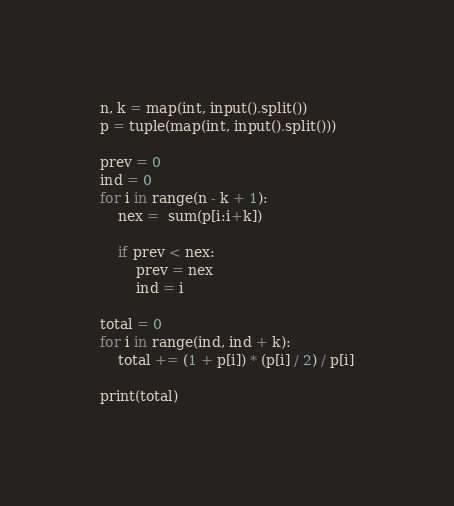<code> <loc_0><loc_0><loc_500><loc_500><_Python_>n, k = map(int, input().split())
p = tuple(map(int, input().split()))

prev = 0
ind = 0
for i in range(n - k + 1):
    nex =  sum(p[i:i+k])

    if prev < nex:
        prev = nex
        ind = i

total = 0
for i in range(ind, ind + k):
    total += (1 + p[i]) * (p[i] / 2) / p[i]

print(total)
</code> 